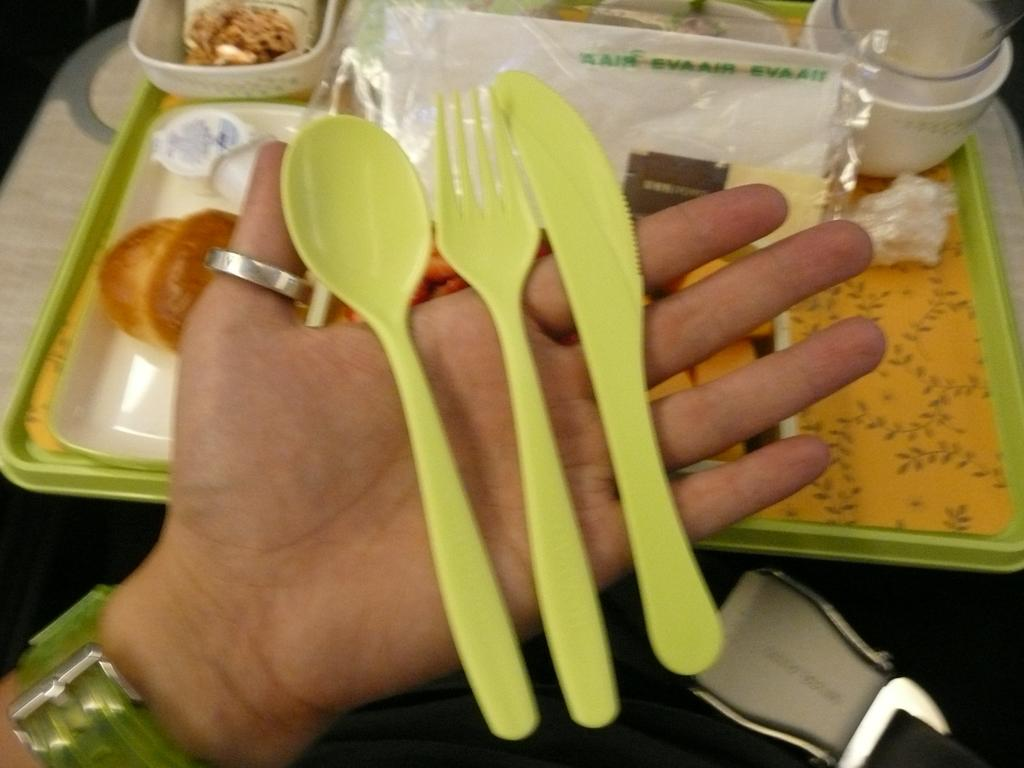What type of utensil is visible in the image? There is a plastic spoon in the image. What other utensil can be seen in the image? There is a fork in the image. Who is holding the fork in the image? The fork is being held in someone's hand. What is the arrangement of the cups in the image? The cups are in a tray in the image. What type of balls can be seen in the zoo territory in the image? There is no reference to balls, a zoo, or territory in the image; it only features utensils and cups. 